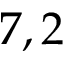<formula> <loc_0><loc_0><loc_500><loc_500>7 , 2</formula> 